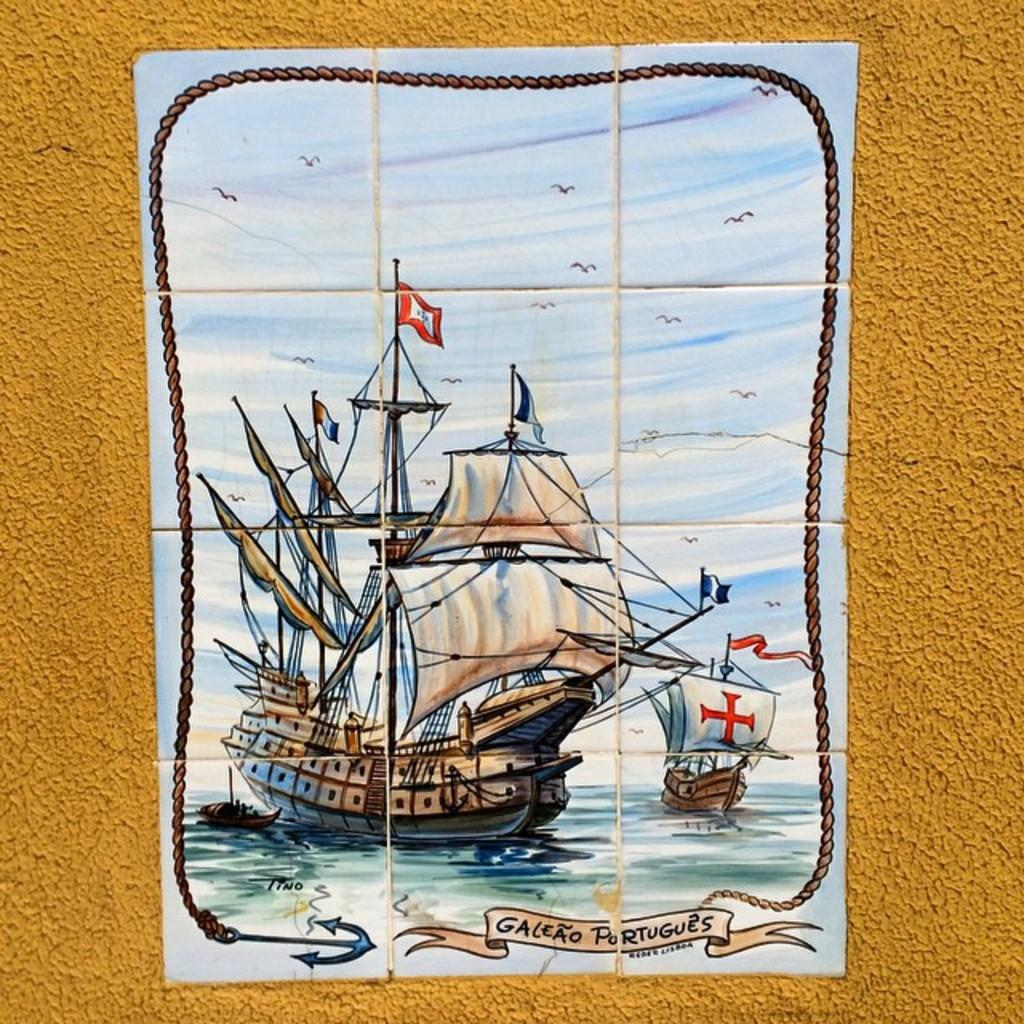Provide a one-sentence caption for the provided image. a tile that says galeao portugues on it. 